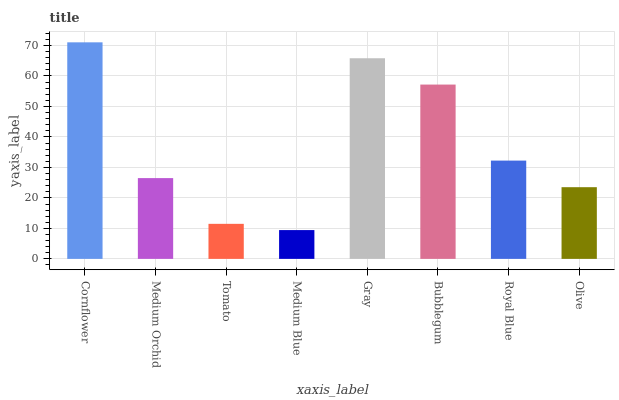Is Medium Orchid the minimum?
Answer yes or no. No. Is Medium Orchid the maximum?
Answer yes or no. No. Is Cornflower greater than Medium Orchid?
Answer yes or no. Yes. Is Medium Orchid less than Cornflower?
Answer yes or no. Yes. Is Medium Orchid greater than Cornflower?
Answer yes or no. No. Is Cornflower less than Medium Orchid?
Answer yes or no. No. Is Royal Blue the high median?
Answer yes or no. Yes. Is Medium Orchid the low median?
Answer yes or no. Yes. Is Cornflower the high median?
Answer yes or no. No. Is Bubblegum the low median?
Answer yes or no. No. 